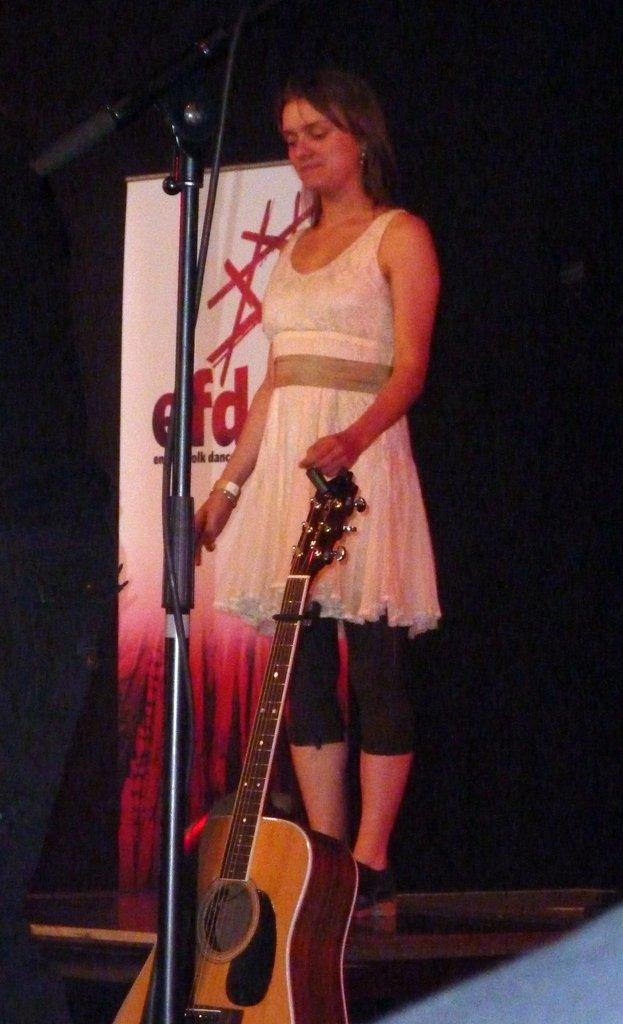Who is the main subject in the image? There is a girl in the image. What is the girl doing in the image? The girl is catching a guitar in the image. What is the girl standing near in the image? The girl is standing in front of a microphone in the image. What else can be seen near the girl in the image? There is a banner near the girl in the image. What type of cactus can be seen in the background of the image? There is no cactus present in the image. Is there a fireman in the image helping the girl with the guitar? There is no fireman present in the image; the girl is the main subject and is catching a guitar. 